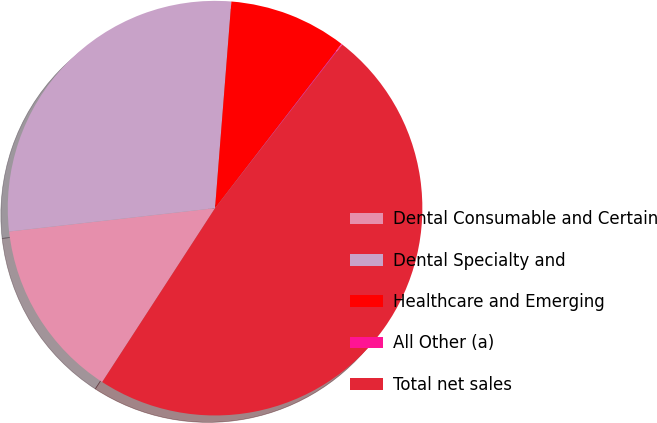Convert chart. <chart><loc_0><loc_0><loc_500><loc_500><pie_chart><fcel>Dental Consumable and Certain<fcel>Dental Specialty and<fcel>Healthcare and Emerging<fcel>All Other (a)<fcel>Total net sales<nl><fcel>14.04%<fcel>28.05%<fcel>9.19%<fcel>0.07%<fcel>48.65%<nl></chart> 